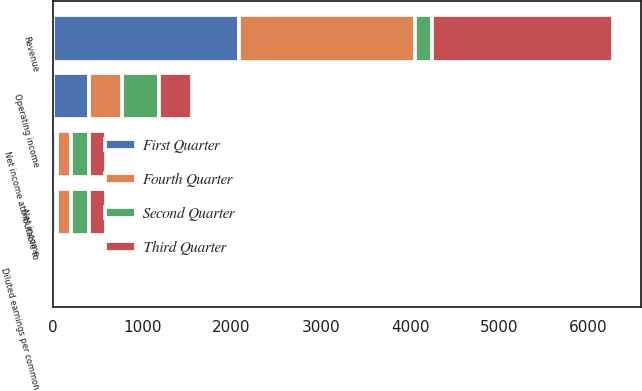Convert chart to OTSL. <chart><loc_0><loc_0><loc_500><loc_500><stacked_bar_chart><ecel><fcel>Revenue<fcel>Operating income<fcel>Net income<fcel>Net income attributable to<fcel>Diluted earnings per common<nl><fcel>Fourth Quarter<fcel>1964.9<fcel>376.2<fcel>158.1<fcel>158.2<fcel>0.41<nl><fcel>First Quarter<fcel>2086.6<fcel>401.2<fcel>46.2<fcel>46.5<fcel>0.12<nl><fcel>Second Quarter<fcel>191<fcel>408.5<fcel>193.6<fcel>193.5<fcel>0.52<nl><fcel>Third Quarter<fcel>2025.2<fcel>366.7<fcel>191<fcel>191<fcel>0.51<nl></chart> 